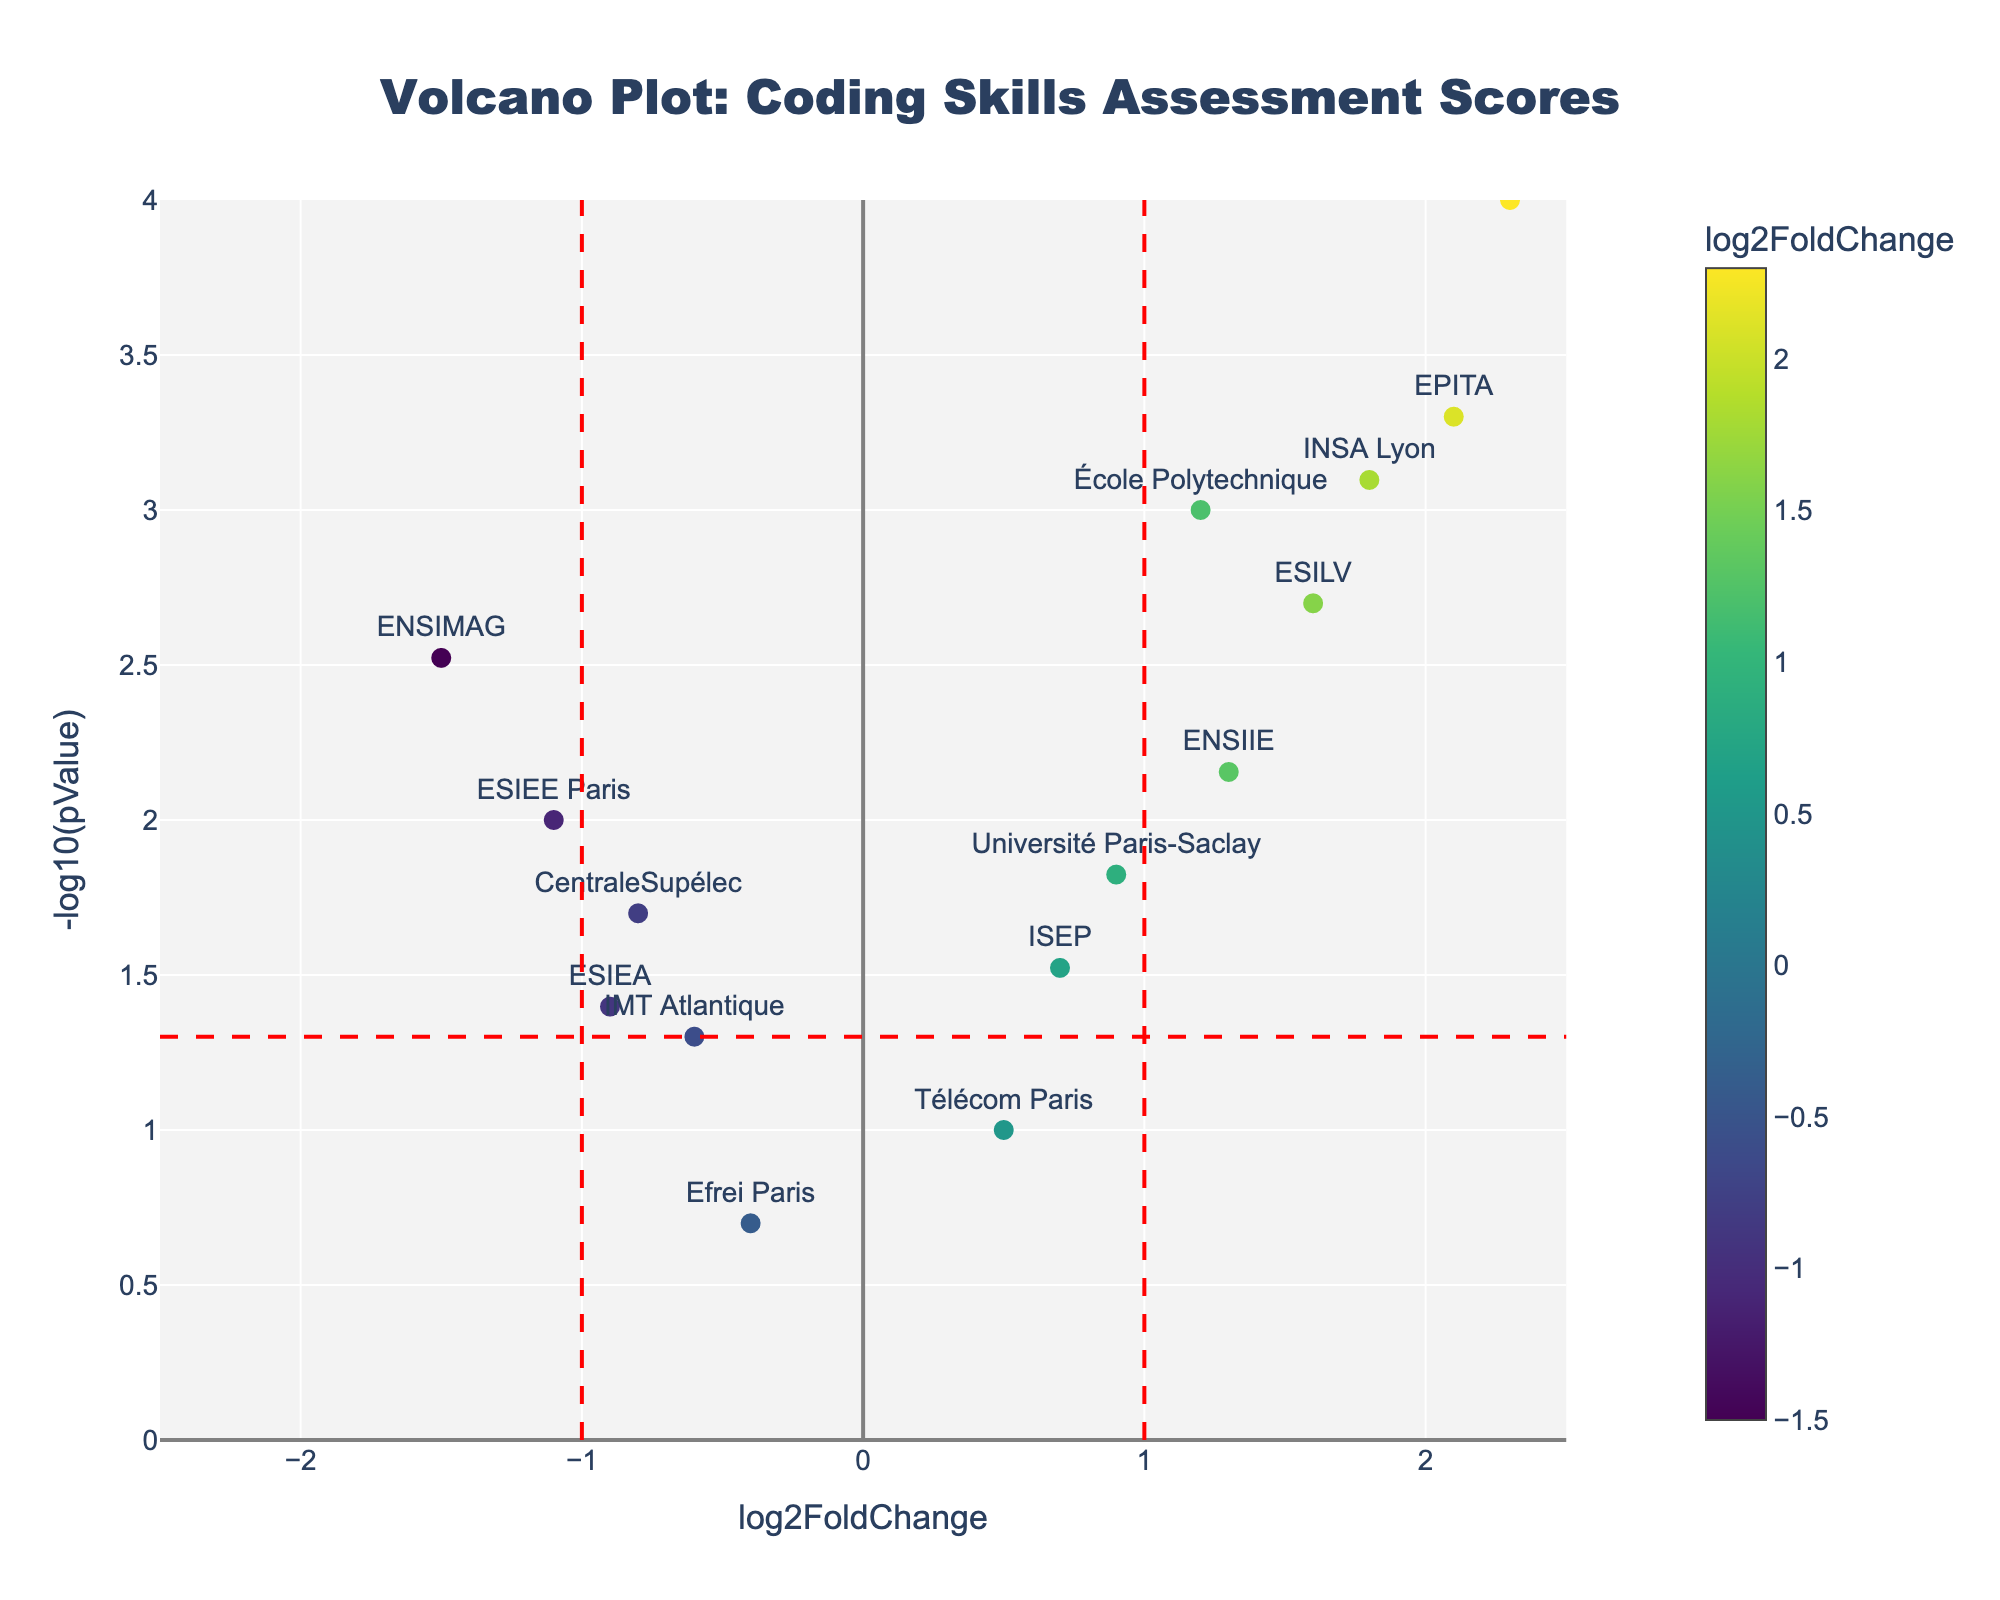What is the title of the figure? The title of the figure is displayed at the top center. It is "Volcano Plot: Coding Skills Assessment Scores"
Answer: Volcano Plot: Coding Skills Assessment Scores Which university program has the highest log2FoldChange value? To determine this, we look for the data point with the highest x-axis value. Epitech has the highest log2FoldChange value of 2.3
Answer: Epitech How many university programs have a p-value less than 0.05? To find this, we look for points above the horizontal red dashed line. There are 10 such points.
Answer: 10 Which university programs are considered significant and have a positive log2FoldChange value? Significant points are above the -log10(0.05) horizontal line, and positive log2FoldChange means they are to the right of the central vertical line. These points are École Polytechnique, EPITA, Université Paris-Saclay, INSA Lyon, ENSIIE, ESILV, and Epitech.
Answer: École Polytechnique, EPITA, Université Paris-Saclay, INSA Lyon, ENSIIE, ESILV, Epitech Compare the log2FoldChange values for École Polytechnique and EPITA and state which one is higher. École Polytechnique has a log2FoldChange of 1.2 and EPITA has 2.1, meaning EPITA is higher.
Answer: EPITA Which university program has the lowest p-value and what is it? The lowest p-value corresponds to the highest -log10(pValue) point. Epitech has the lowest p-value of 0.0001.
Answer: Epitech Are there any university programs with a log2FoldChange value between -0.5 and 0.5? To check this, observe data points between -0.5 and 0.5 on the x-axis. Télécom Paris has a log2FoldChange value of 0.5, and Efrei Paris has -0.4.
Answer: Télécom Paris, Efrei Paris Which university programs have a negative log2FoldChange value? Programs with negative log2FoldChange are on the left side of the central vertical line. These are CentraleSupélec, ENSIMAG, IMT Atlantique, ESIEE Paris, Efrei Paris, and ESIEA.
Answer: CentraleSupélec, ENSIMAG, IMT Atlantique, ESIEE Paris, Efrei Paris, ESIEA What is the log2FoldChange threshold marked by the red dashed vertical lines in the plot? The red dashed vertical lines are placed at log2FoldChange values of -1 and 1, creating thresholds for log2FoldChange
Answer: -1 and 1 Which data points are closest to the origin, and what does this imply? The data points closest to the origin are Efrei Paris with log2FoldChange -0.4 and Télécom Paris with log2FoldChange 0.5. This implies their scores are relatively average compared to others.
Answer: Efrei Paris, Télécom Paris 